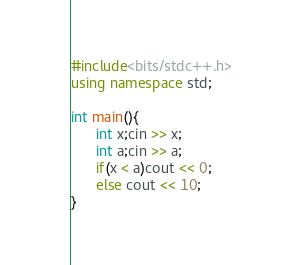<code> <loc_0><loc_0><loc_500><loc_500><_C++_>#include<bits/stdc++.h>
using namespace std;

int main(){
      int x;cin >> x;
      int a;cin >> a;
      if(x < a)cout << 0;
      else cout << 10;
}</code> 